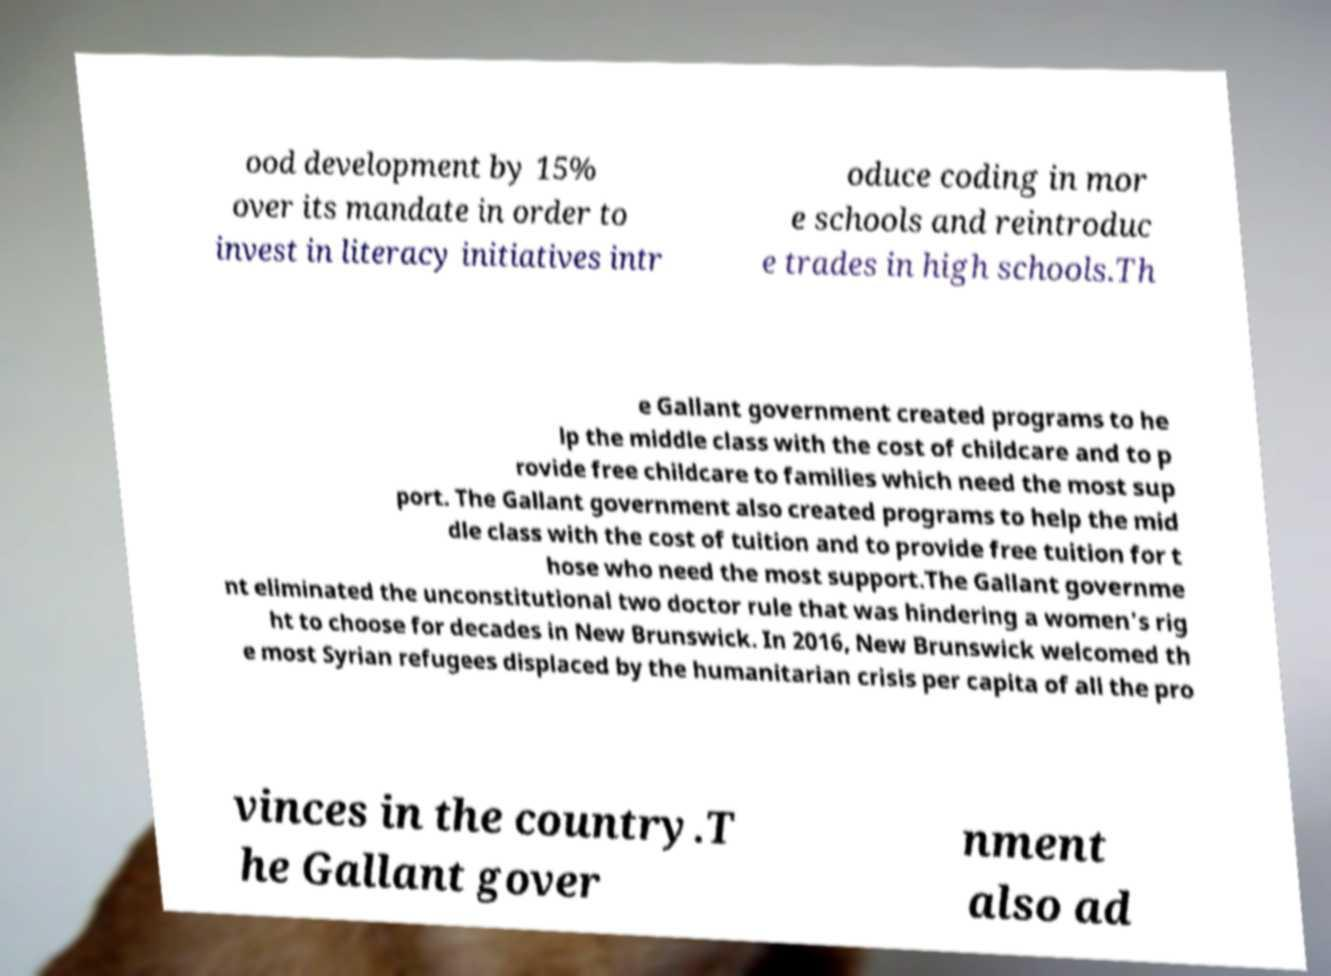Please read and relay the text visible in this image. What does it say? ood development by 15% over its mandate in order to invest in literacy initiatives intr oduce coding in mor e schools and reintroduc e trades in high schools.Th e Gallant government created programs to he lp the middle class with the cost of childcare and to p rovide free childcare to families which need the most sup port. The Gallant government also created programs to help the mid dle class with the cost of tuition and to provide free tuition for t hose who need the most support.The Gallant governme nt eliminated the unconstitutional two doctor rule that was hindering a women's rig ht to choose for decades in New Brunswick. In 2016, New Brunswick welcomed th e most Syrian refugees displaced by the humanitarian crisis per capita of all the pro vinces in the country.T he Gallant gover nment also ad 